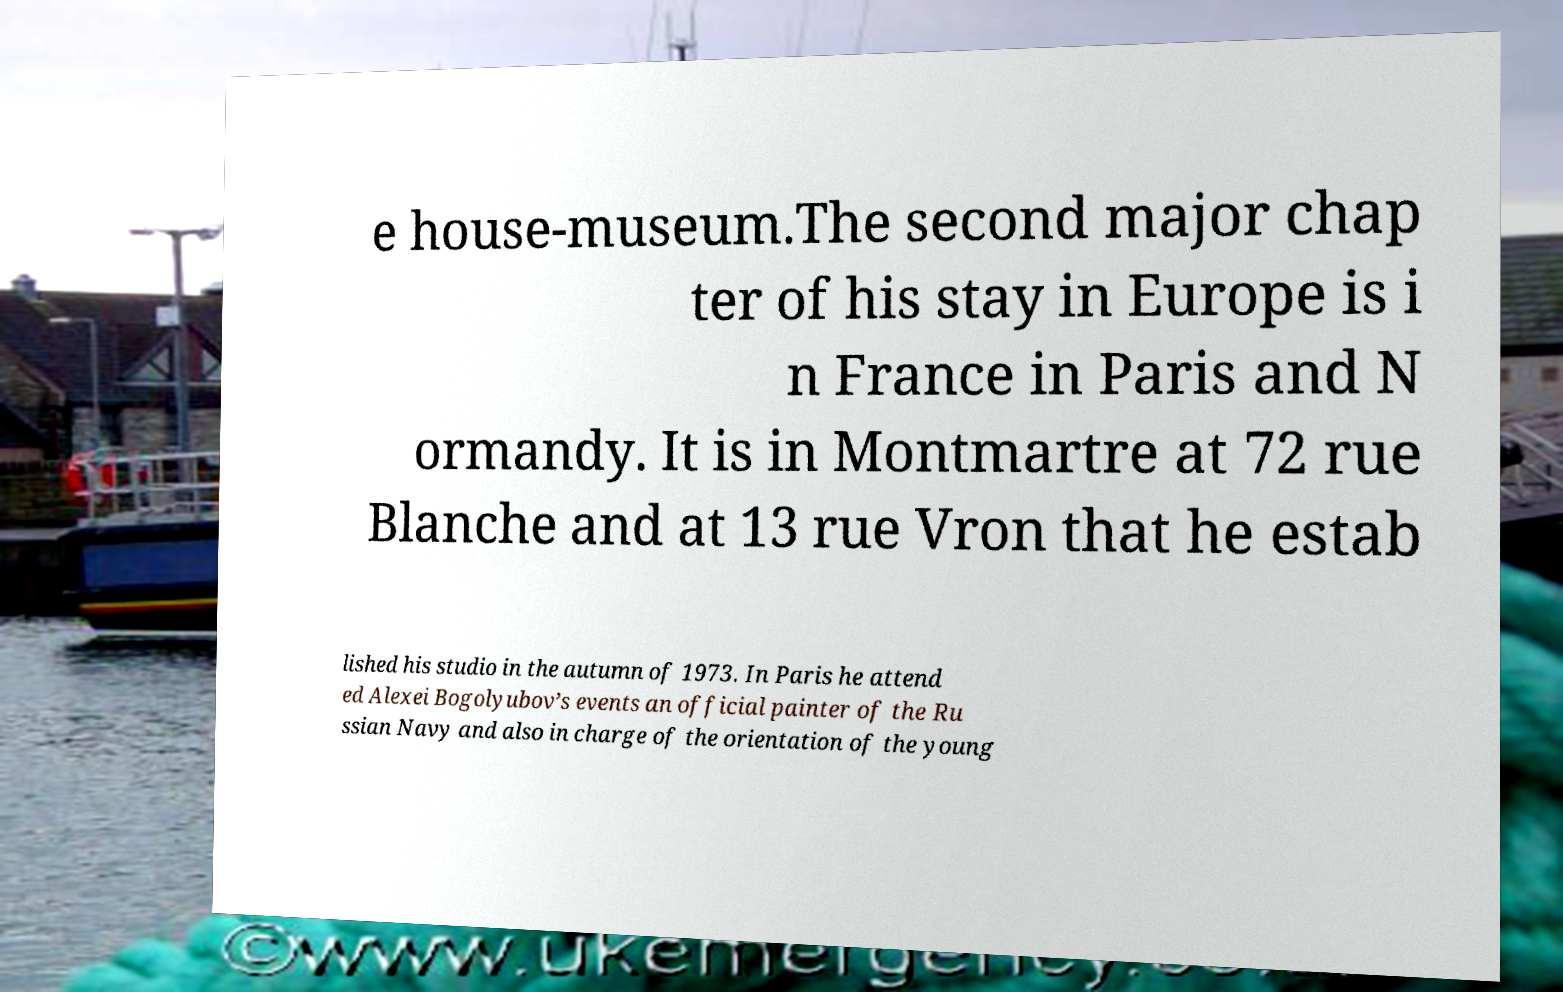Can you read and provide the text displayed in the image?This photo seems to have some interesting text. Can you extract and type it out for me? e house-museum.The second major chap ter of his stay in Europe is i n France in Paris and N ormandy. It is in Montmartre at 72 rue Blanche and at 13 rue Vron that he estab lished his studio in the autumn of 1973. In Paris he attend ed Alexei Bogolyubov’s events an official painter of the Ru ssian Navy and also in charge of the orientation of the young 